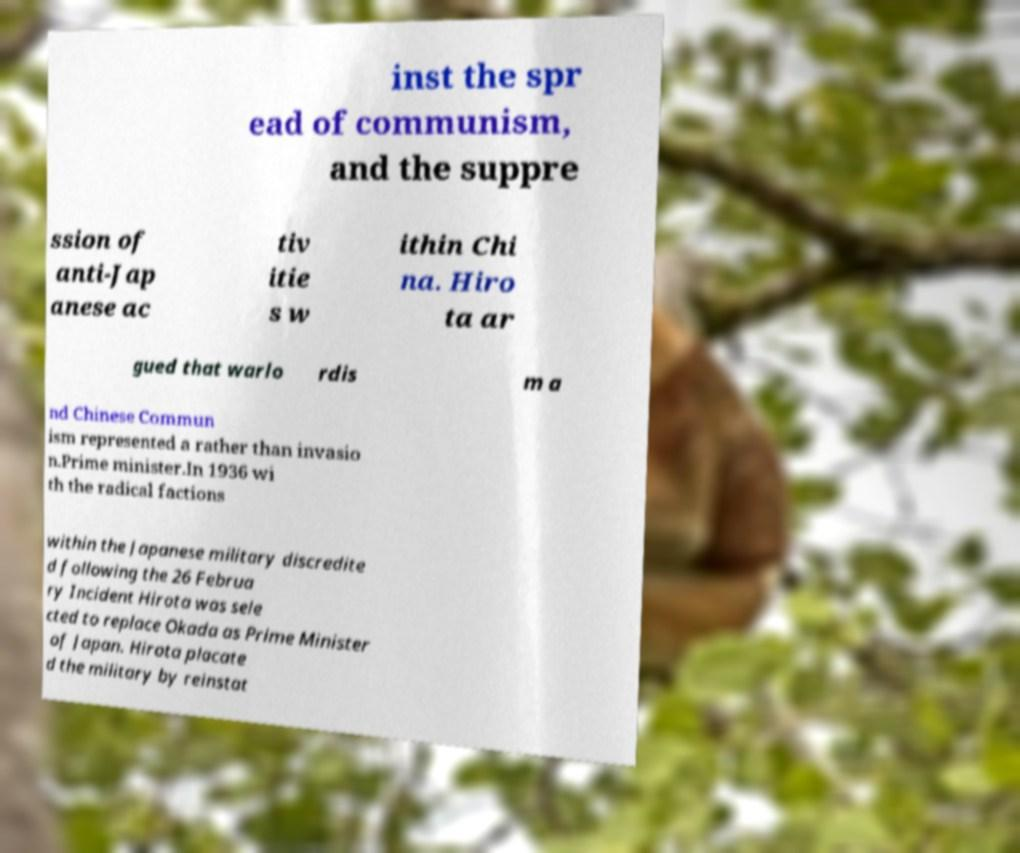Can you accurately transcribe the text from the provided image for me? inst the spr ead of communism, and the suppre ssion of anti-Jap anese ac tiv itie s w ithin Chi na. Hiro ta ar gued that warlo rdis m a nd Chinese Commun ism represented a rather than invasio n.Prime minister.In 1936 wi th the radical factions within the Japanese military discredite d following the 26 Februa ry Incident Hirota was sele cted to replace Okada as Prime Minister of Japan. Hirota placate d the military by reinstat 